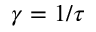Convert formula to latex. <formula><loc_0><loc_0><loc_500><loc_500>\gamma = 1 / \tau</formula> 